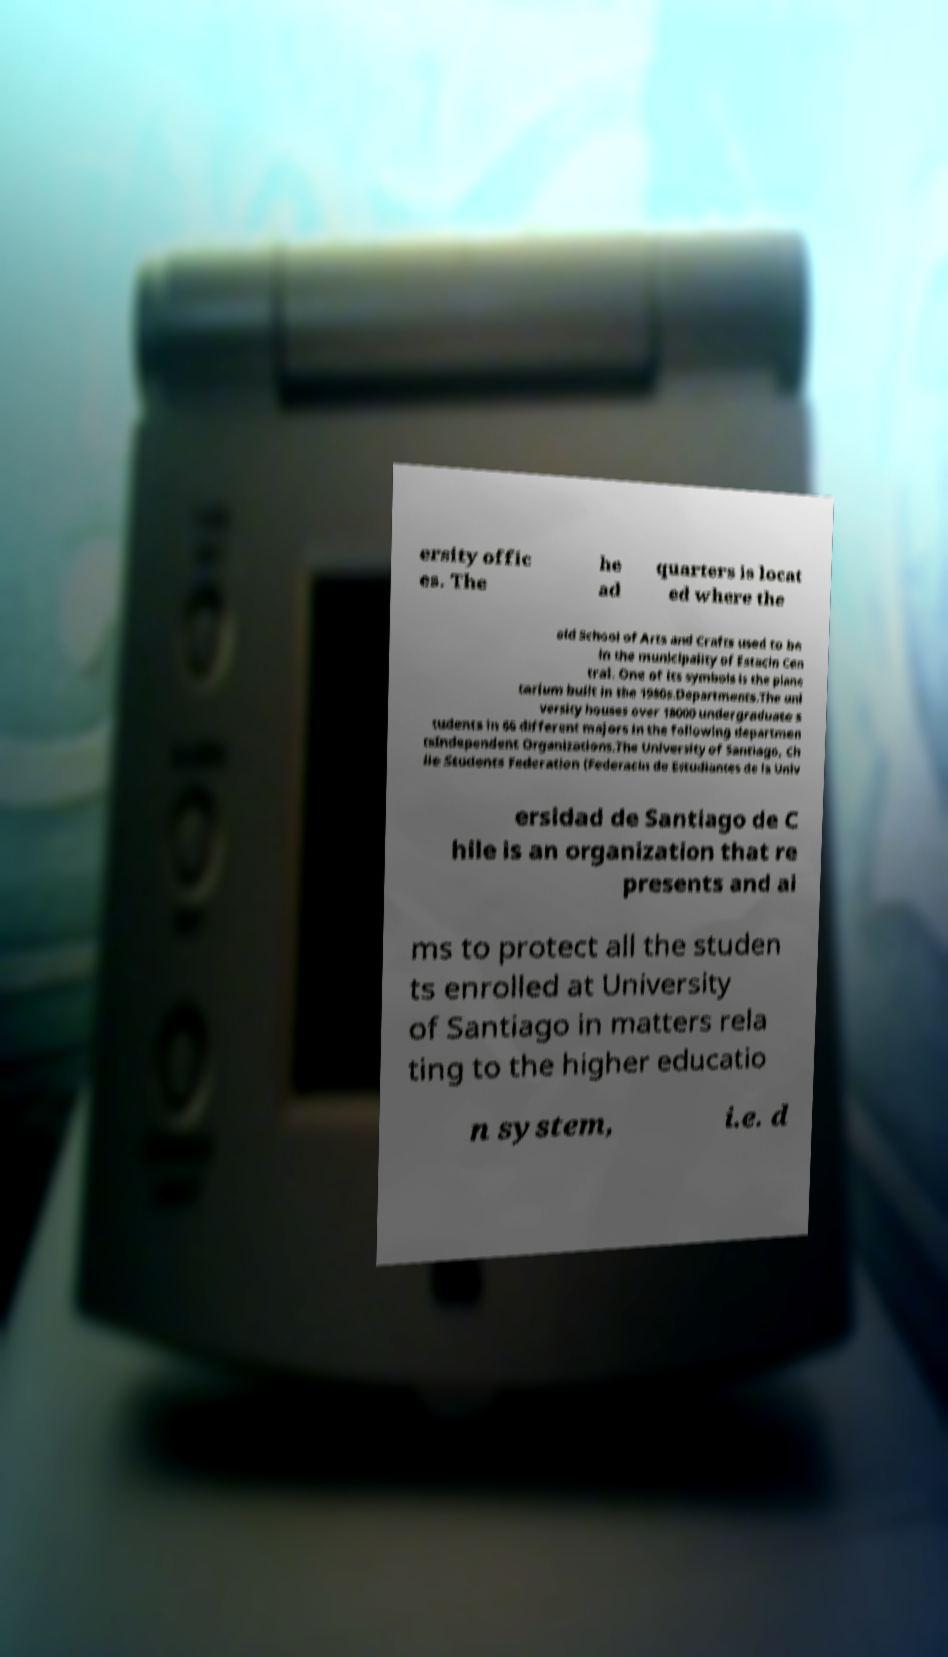What messages or text are displayed in this image? I need them in a readable, typed format. ersity offic es. The he ad quarters is locat ed where the old School of Arts and Crafts used to be in the municipality of Estacin Cen tral. One of its symbols is the plane tarium built in the 1980s.Departments.The uni versity houses over 18000 undergraduate s tudents in 66 different majors in the following departmen tsIndependent Organizations.The University of Santiago, Ch ile Students Federation (Federacin de Estudiantes de la Univ ersidad de Santiago de C hile is an organization that re presents and ai ms to protect all the studen ts enrolled at University of Santiago in matters rela ting to the higher educatio n system, i.e. d 